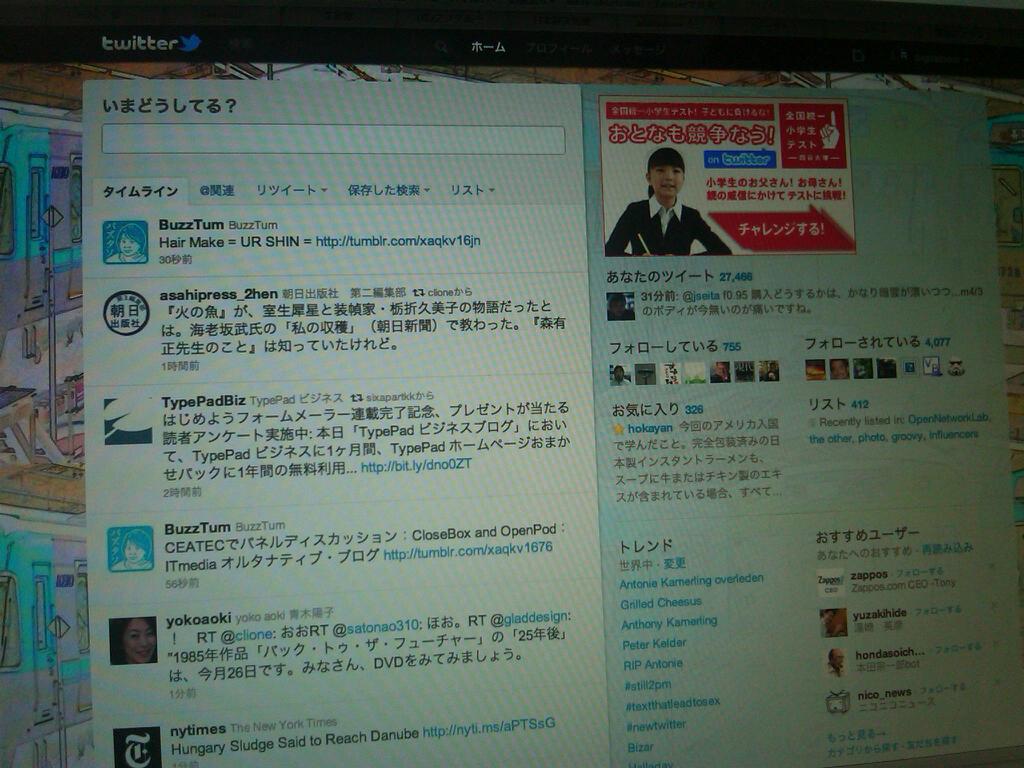Did buzztum comment?
Your answer should be compact. Yes. Who commented on this?
Give a very brief answer. Unanswerable. 